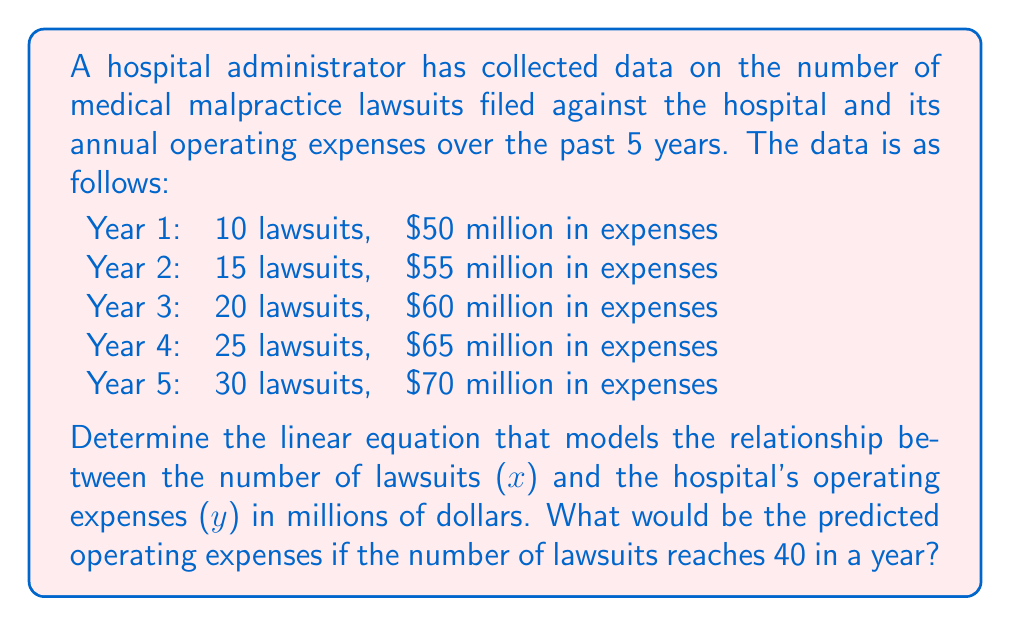Provide a solution to this math problem. To find the linear equation, we'll use the slope-intercept form: $y = mx + b$, where $m$ is the slope and $b$ is the y-intercept.

Step 1: Calculate the slope (m)
We can use any two points to calculate the slope. Let's use the first and last data points:
$m = \frac{y_2 - y_1}{x_2 - x_1} = \frac{70 - 50}{30 - 10} = \frac{20}{20} = 1$

Step 2: Use the point-slope form to find the y-intercept (b)
Using the point (10, 50) and the slope we found:
$y - y_1 = m(x - x_1)$
$y - 50 = 1(x - 10)$
$y = x - 10 + 50$
$y = x + 40$

So, our linear equation is $y = x + 40$

Step 3: Predict the operating expenses for 40 lawsuits
Substitute $x = 40$ into our equation:
$y = 40 + 40 = 80$

Therefore, if there are 40 lawsuits in a year, the predicted operating expenses would be $80 million.
Answer: $y = x + 40$; $80 million 